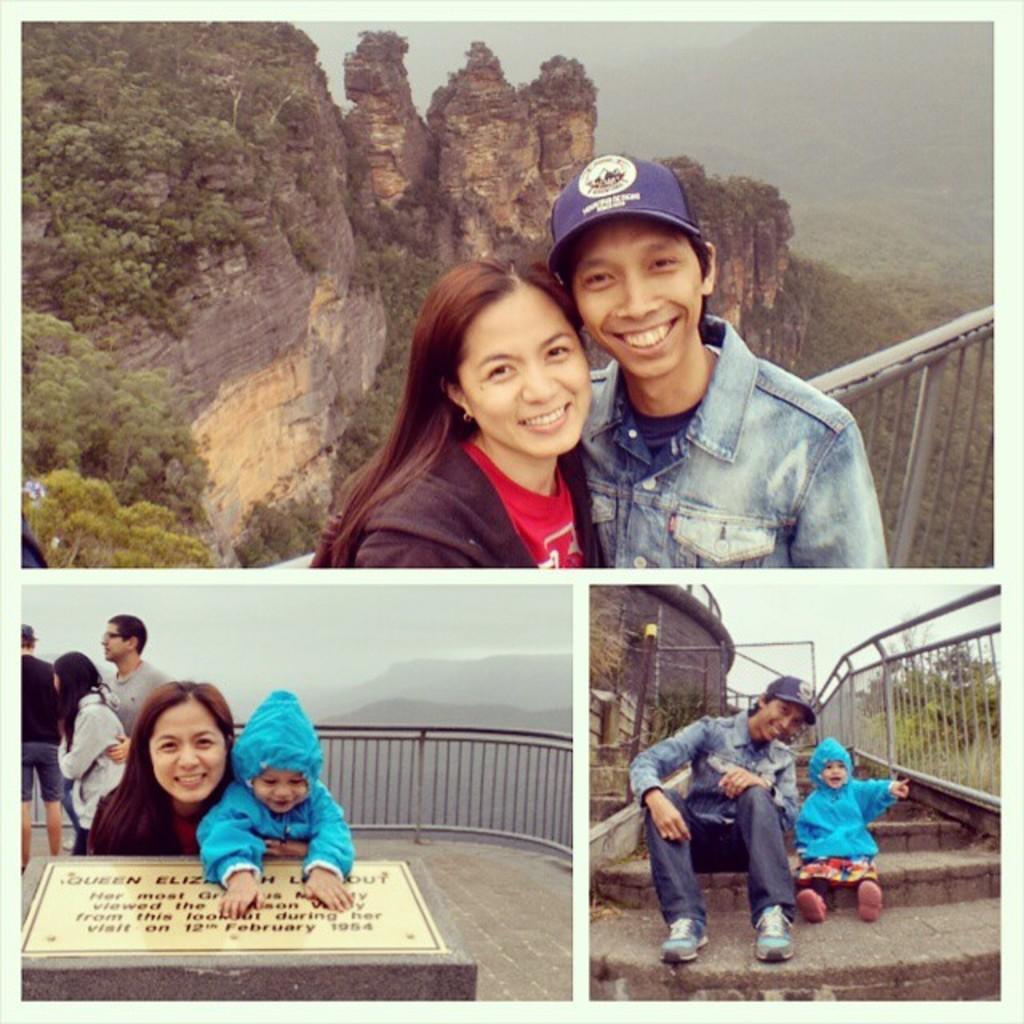In one or two sentences, can you explain what this image depicts? This image looks like an edited photo, in which I can see a group of people, memorial, fence, steps, trees, mountains and the sky. 